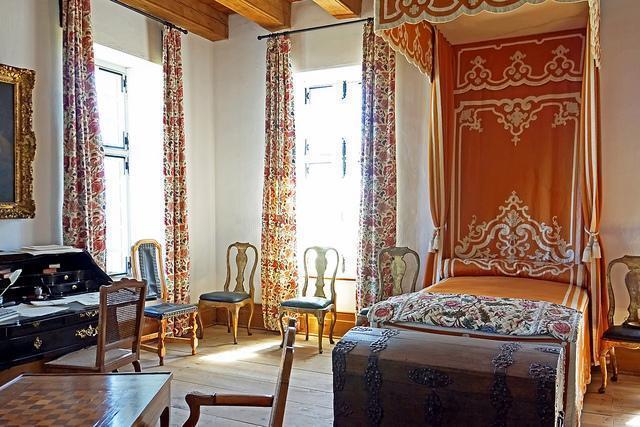What is the brown table at the left bottom corner for?
Indicate the correct response and explain using: 'Answer: answer
Rationale: rationale.'
Options: Preparing food, reading desk, coffee table, playing chess. Answer: playing chess.
Rationale: The table is a chess table given the checkerboard pattern. 